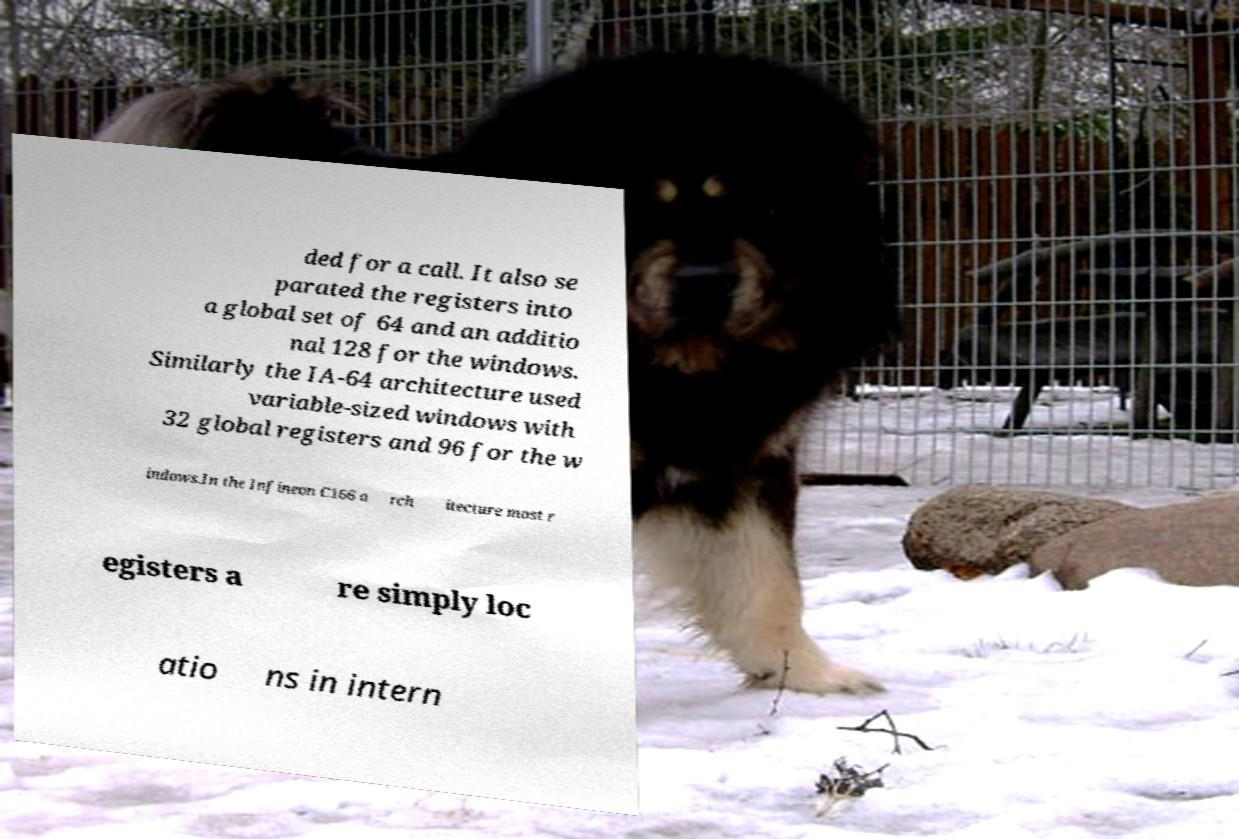Please read and relay the text visible in this image. What does it say? ded for a call. It also se parated the registers into a global set of 64 and an additio nal 128 for the windows. Similarly the IA-64 architecture used variable-sized windows with 32 global registers and 96 for the w indows.In the Infineon C166 a rch itecture most r egisters a re simply loc atio ns in intern 